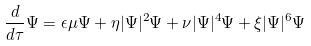Convert formula to latex. <formula><loc_0><loc_0><loc_500><loc_500>\frac { d } { d \tau } \Psi = \epsilon \mu \Psi + \eta | \Psi | ^ { 2 } \Psi + \nu | \Psi | ^ { 4 } \Psi + \xi | \Psi | ^ { 6 } \Psi</formula> 